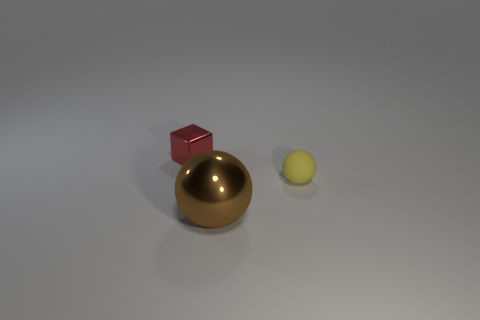Add 2 big gray metal cylinders. How many objects exist? 5 Subtract all brown spheres. How many spheres are left? 1 Subtract all cubes. How many objects are left? 2 Subtract 0 blue blocks. How many objects are left? 3 Subtract all blue blocks. Subtract all blue spheres. How many blocks are left? 1 Subtract all yellow things. Subtract all small metal cubes. How many objects are left? 1 Add 1 brown metal objects. How many brown metal objects are left? 2 Add 1 tiny metallic cubes. How many tiny metallic cubes exist? 2 